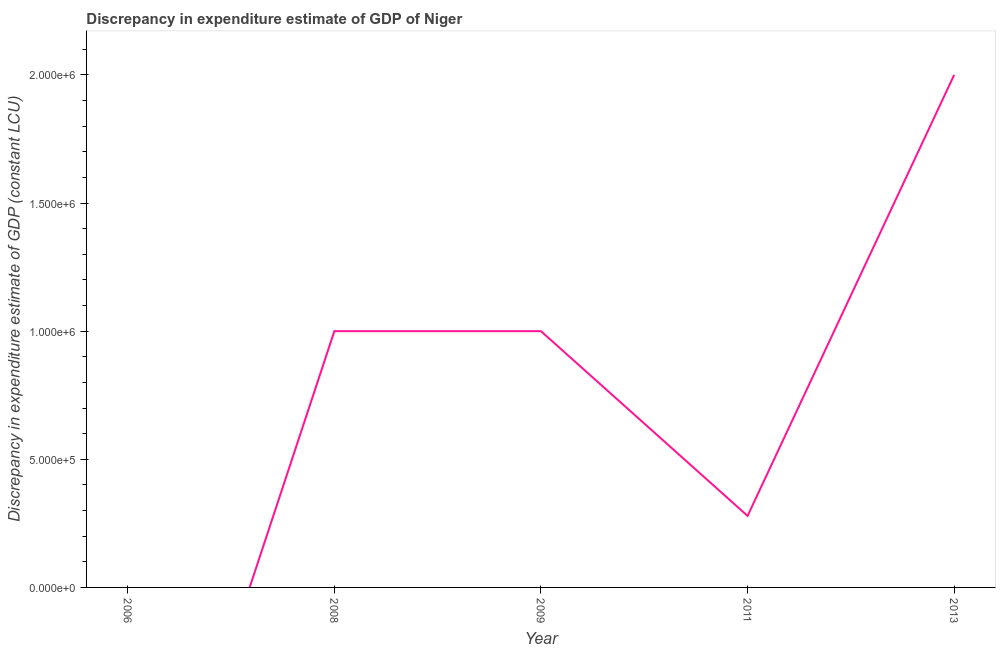What is the discrepancy in expenditure estimate of gdp in 2008?
Your response must be concise. 1.00e+06. Across all years, what is the maximum discrepancy in expenditure estimate of gdp?
Give a very brief answer. 2.00e+06. What is the sum of the discrepancy in expenditure estimate of gdp?
Provide a short and direct response. 4.28e+06. What is the difference between the discrepancy in expenditure estimate of gdp in 2011 and 2013?
Make the answer very short. -1.72e+06. What is the average discrepancy in expenditure estimate of gdp per year?
Offer a terse response. 8.56e+05. What is the median discrepancy in expenditure estimate of gdp?
Ensure brevity in your answer.  1.00e+06. In how many years, is the discrepancy in expenditure estimate of gdp greater than 700000 LCU?
Make the answer very short. 3. What is the ratio of the discrepancy in expenditure estimate of gdp in 2008 to that in 2009?
Offer a terse response. 1. Is the difference between the discrepancy in expenditure estimate of gdp in 2009 and 2013 greater than the difference between any two years?
Give a very brief answer. No. What is the difference between the highest and the second highest discrepancy in expenditure estimate of gdp?
Your answer should be compact. 1.00e+06. What is the difference between the highest and the lowest discrepancy in expenditure estimate of gdp?
Provide a succinct answer. 2.00e+06. In how many years, is the discrepancy in expenditure estimate of gdp greater than the average discrepancy in expenditure estimate of gdp taken over all years?
Your answer should be very brief. 3. How many lines are there?
Give a very brief answer. 1. How many years are there in the graph?
Your answer should be very brief. 5. What is the difference between two consecutive major ticks on the Y-axis?
Your answer should be compact. 5.00e+05. Are the values on the major ticks of Y-axis written in scientific E-notation?
Your response must be concise. Yes. Does the graph contain grids?
Your answer should be very brief. No. What is the title of the graph?
Your answer should be very brief. Discrepancy in expenditure estimate of GDP of Niger. What is the label or title of the X-axis?
Your answer should be very brief. Year. What is the label or title of the Y-axis?
Offer a very short reply. Discrepancy in expenditure estimate of GDP (constant LCU). What is the Discrepancy in expenditure estimate of GDP (constant LCU) in 2006?
Your answer should be very brief. 0. What is the Discrepancy in expenditure estimate of GDP (constant LCU) in 2011?
Make the answer very short. 2.79e+05. What is the difference between the Discrepancy in expenditure estimate of GDP (constant LCU) in 2008 and 2009?
Offer a very short reply. 0. What is the difference between the Discrepancy in expenditure estimate of GDP (constant LCU) in 2008 and 2011?
Offer a terse response. 7.21e+05. What is the difference between the Discrepancy in expenditure estimate of GDP (constant LCU) in 2009 and 2011?
Offer a terse response. 7.21e+05. What is the difference between the Discrepancy in expenditure estimate of GDP (constant LCU) in 2011 and 2013?
Keep it short and to the point. -1.72e+06. What is the ratio of the Discrepancy in expenditure estimate of GDP (constant LCU) in 2008 to that in 2009?
Offer a very short reply. 1. What is the ratio of the Discrepancy in expenditure estimate of GDP (constant LCU) in 2008 to that in 2011?
Provide a short and direct response. 3.58. What is the ratio of the Discrepancy in expenditure estimate of GDP (constant LCU) in 2009 to that in 2011?
Provide a short and direct response. 3.58. What is the ratio of the Discrepancy in expenditure estimate of GDP (constant LCU) in 2009 to that in 2013?
Keep it short and to the point. 0.5. What is the ratio of the Discrepancy in expenditure estimate of GDP (constant LCU) in 2011 to that in 2013?
Your answer should be compact. 0.14. 